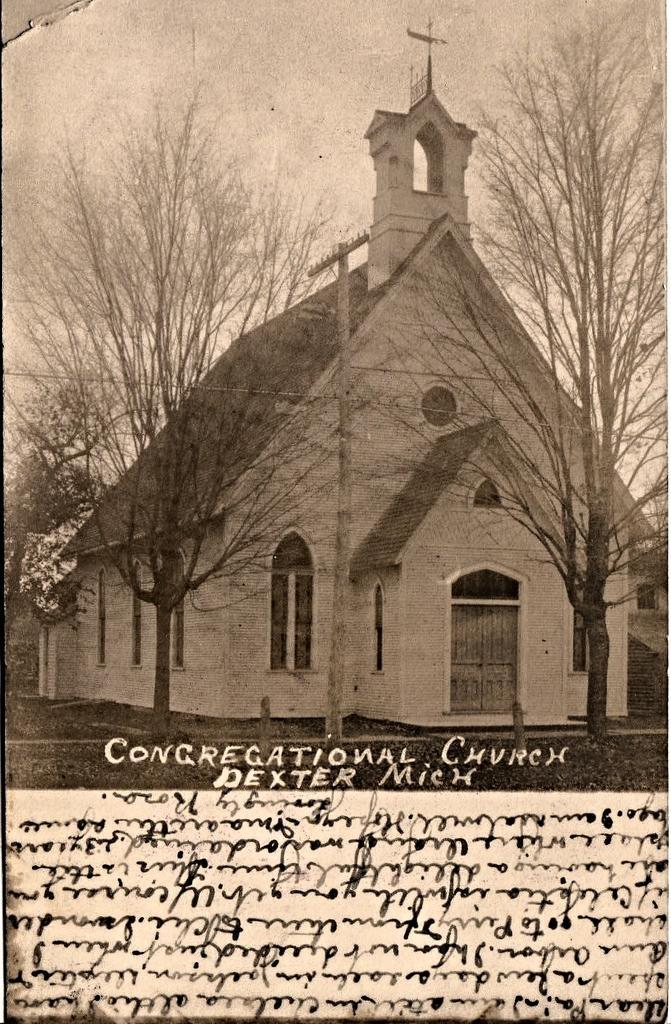Can you describe this image briefly? In the foreground of this poster, on the bottom, there is some text and on the top, there are few trees, a building, poles, grass and the sky. 